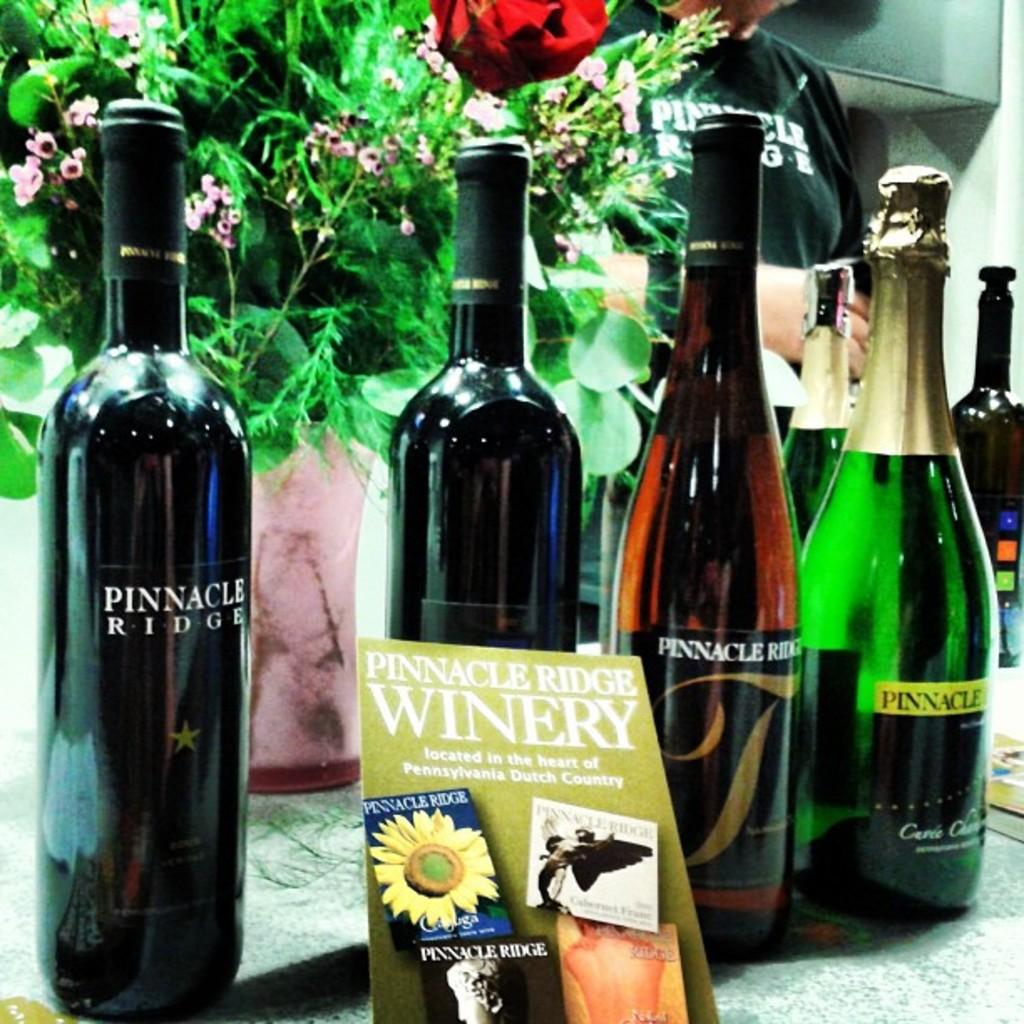<image>
Give a short and clear explanation of the subsequent image. some wine bottles with a winery pamphlet under it 